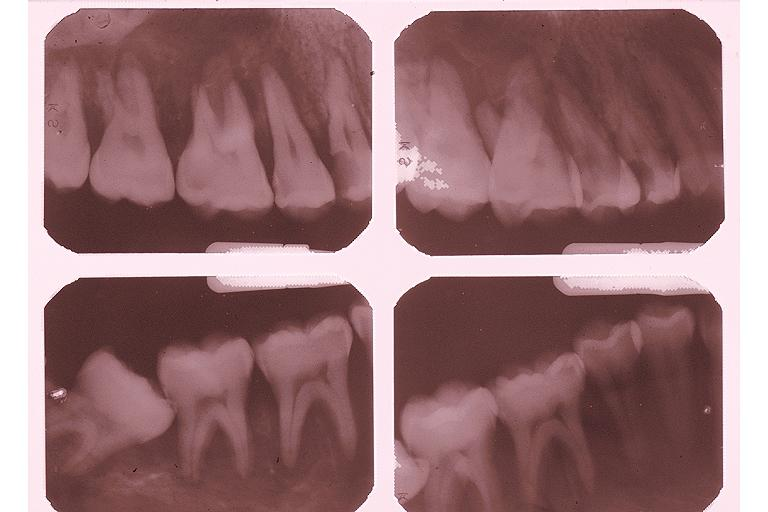what does this image show?
Answer the question using a single word or phrase. Burkits lymphoma 